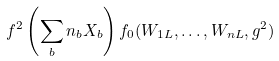<formula> <loc_0><loc_0><loc_500><loc_500>f ^ { 2 } \left ( \sum _ { b } n _ { b } X _ { b } \right ) f _ { 0 } ( W _ { 1 L } , \dots , W _ { n L } , g ^ { 2 } )</formula> 